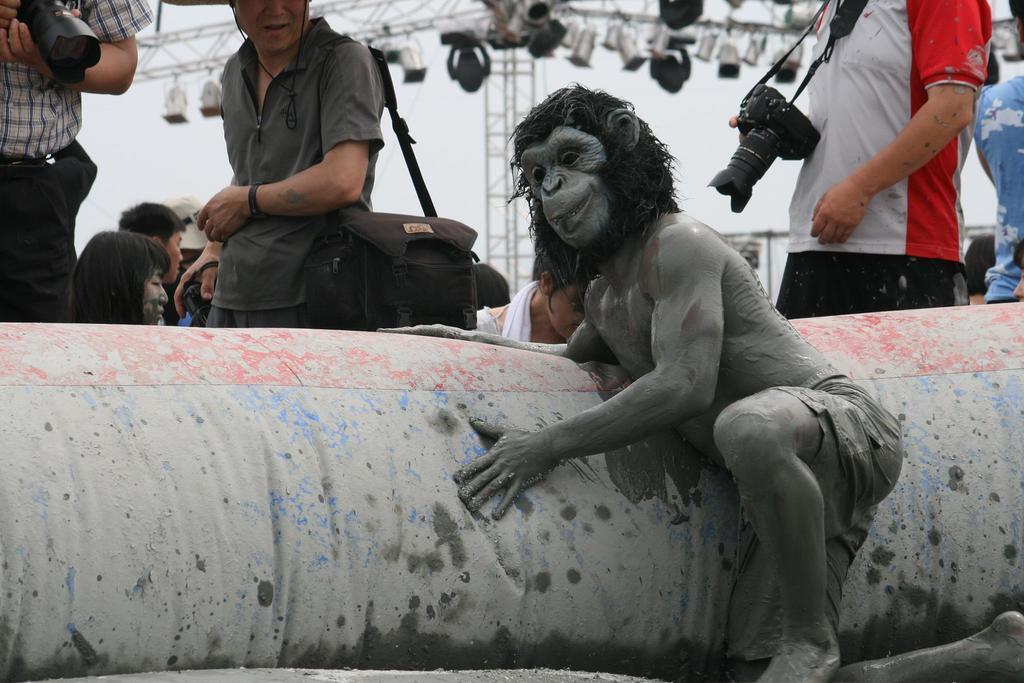In one or two sentences, can you explain what this image depicts? Here in this picture we can see a person present over a place and we can see he is wearing a face mask on him and beside him we can see an balloon type structure present and beside that also we can see other number of people standing and sitting over there , the person on the right side is carrying a camera with him and the person on the left side is carrying a bag and we can also see iron frames with number of lights on it present. 